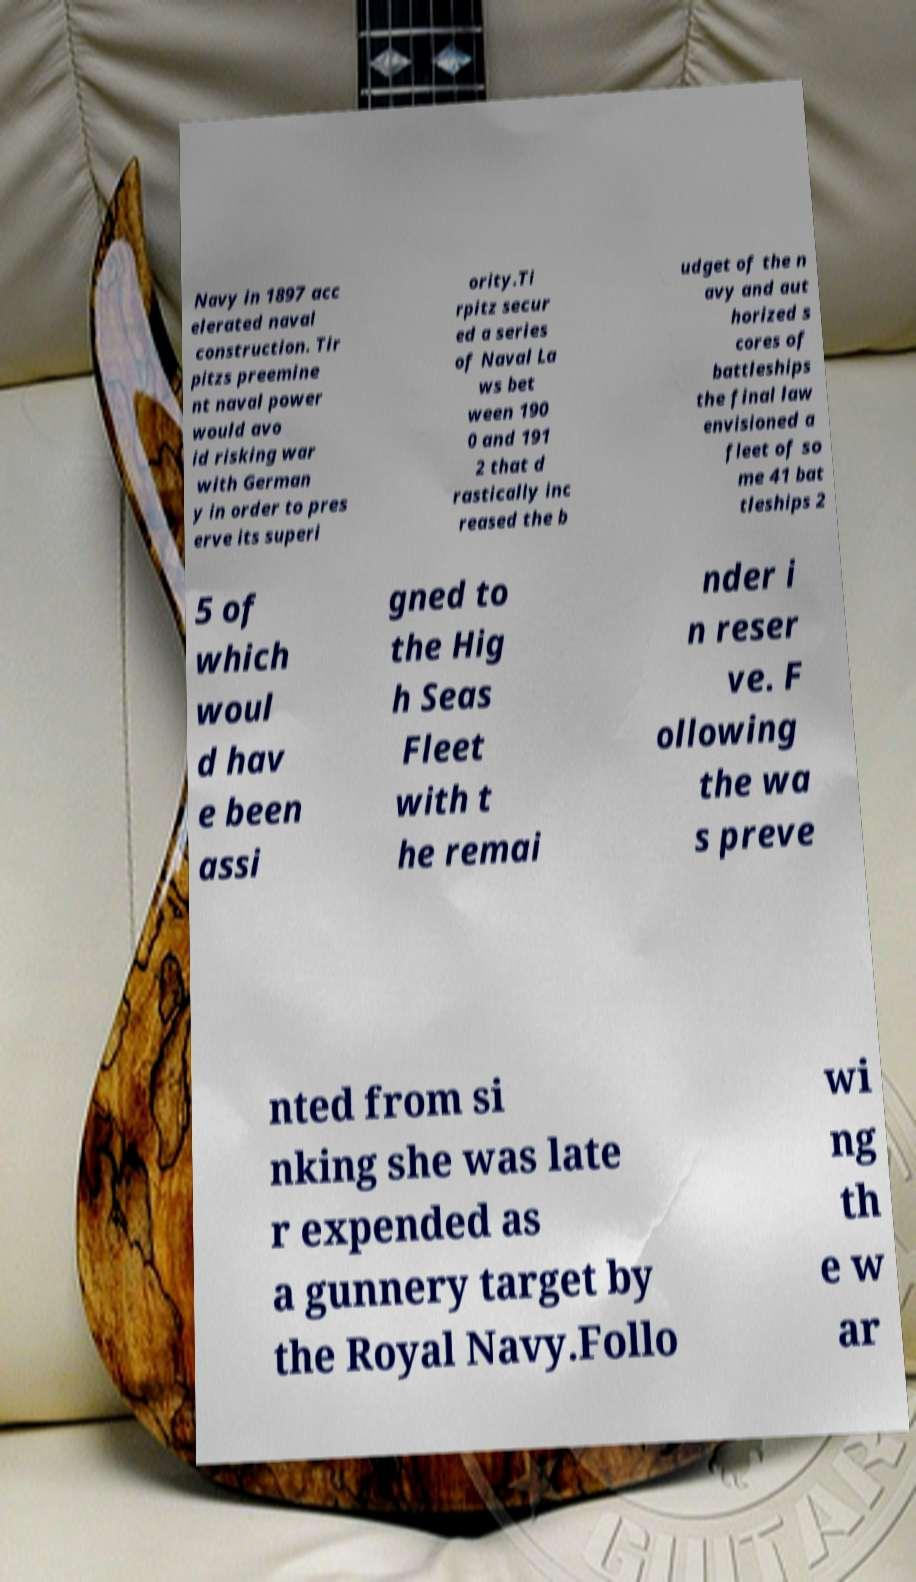What messages or text are displayed in this image? I need them in a readable, typed format. Navy in 1897 acc elerated naval construction. Tir pitzs preemine nt naval power would avo id risking war with German y in order to pres erve its superi ority.Ti rpitz secur ed a series of Naval La ws bet ween 190 0 and 191 2 that d rastically inc reased the b udget of the n avy and aut horized s cores of battleships the final law envisioned a fleet of so me 41 bat tleships 2 5 of which woul d hav e been assi gned to the Hig h Seas Fleet with t he remai nder i n reser ve. F ollowing the wa s preve nted from si nking she was late r expended as a gunnery target by the Royal Navy.Follo wi ng th e w ar 